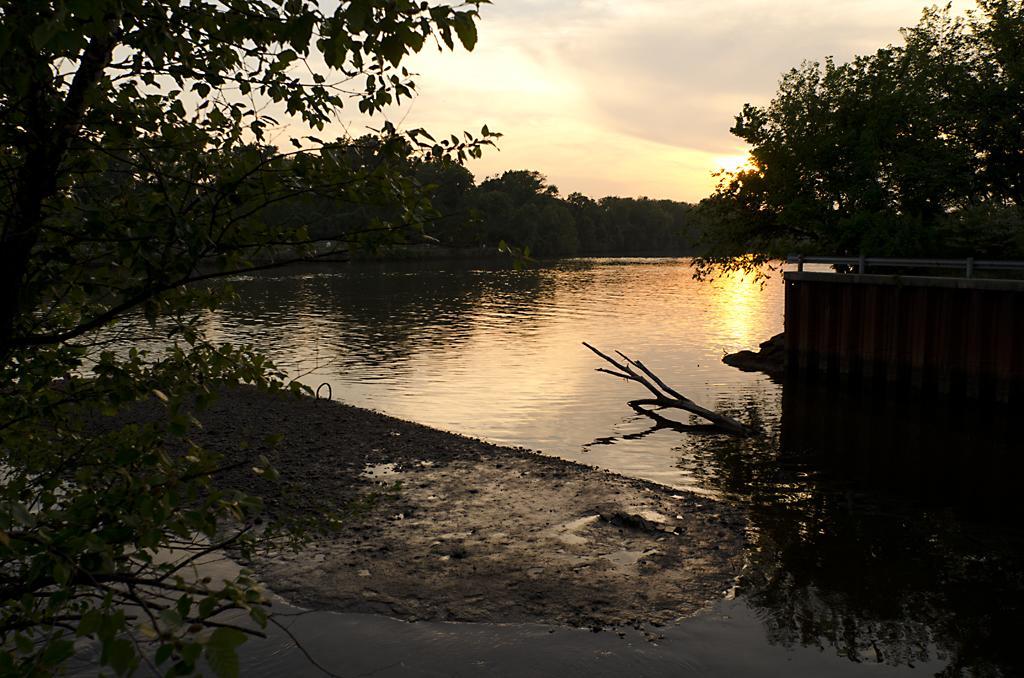Could you give a brief overview of what you see in this image? In this image there are trees and in the center there is a river, and on the right side of the image there is gate. At the bottom there is sand and some water, and in the background there are trees. At the top there is sky. 